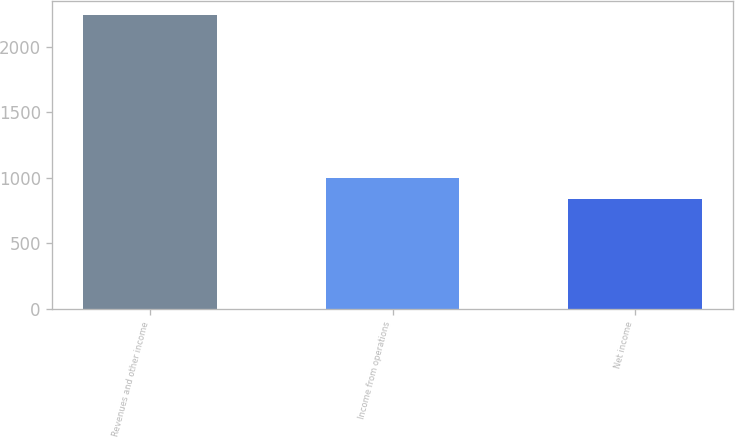Convert chart. <chart><loc_0><loc_0><loc_500><loc_500><bar_chart><fcel>Revenues and other income<fcel>Income from operations<fcel>Net income<nl><fcel>2243<fcel>999<fcel>841<nl></chart> 